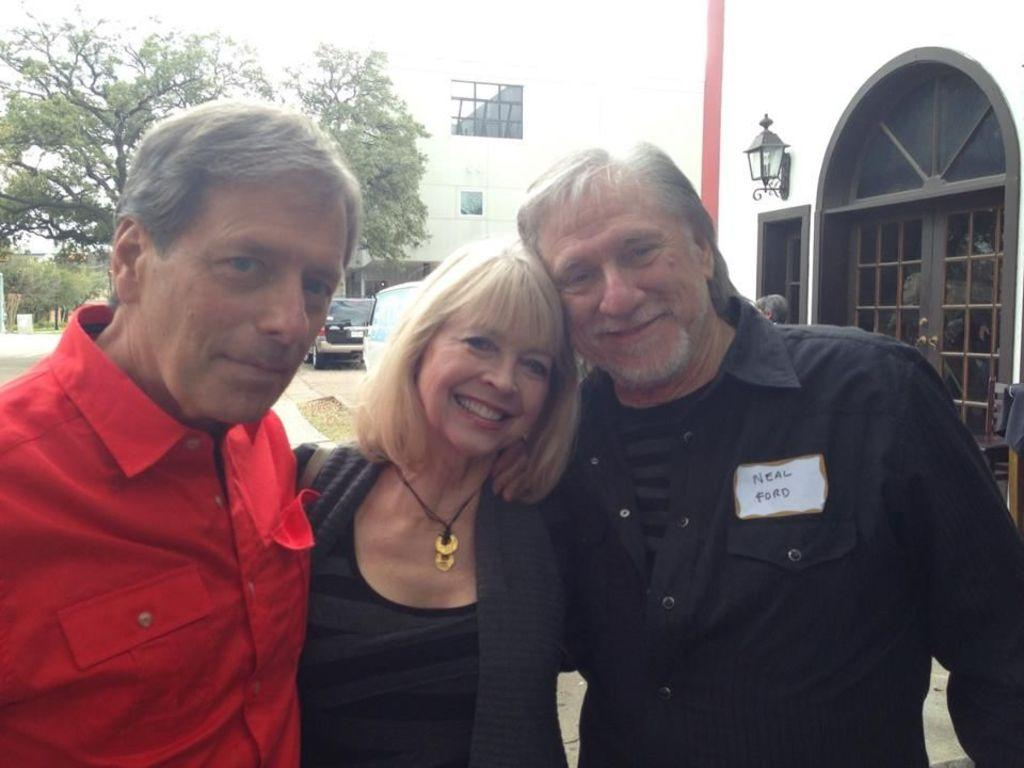How many people are present in the image? There are three persons standing in the image. What can be seen in the background of the image? There are buildings, trees, vehicles, and the sky visible in the background of the image. What type of room is depicted in the image? There is no room present in the image; it is an outdoor scene with people standing and various background elements. 